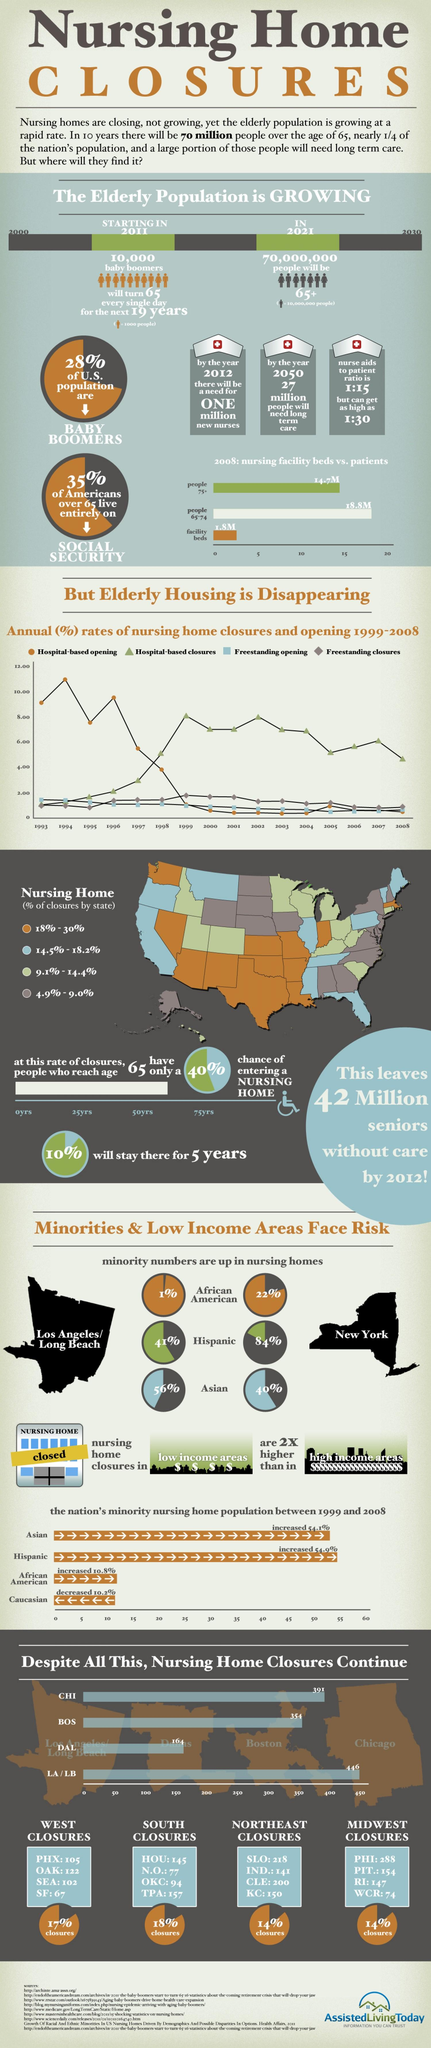Specify some key components in this picture. The percentage of Hispanics in both Los Angeles and New York who are residing in nursing homes is significantly higher than 100%. A significant portion, approximately 72%, of the U.S. population is not baby boomers. A significant percentage of Americans over the age of 65 do not rely entirely on Social Security for their livelihood. According to data, the percentage of African Americans in Los Angeles and New York who are residing in nursing homes is 23%. 